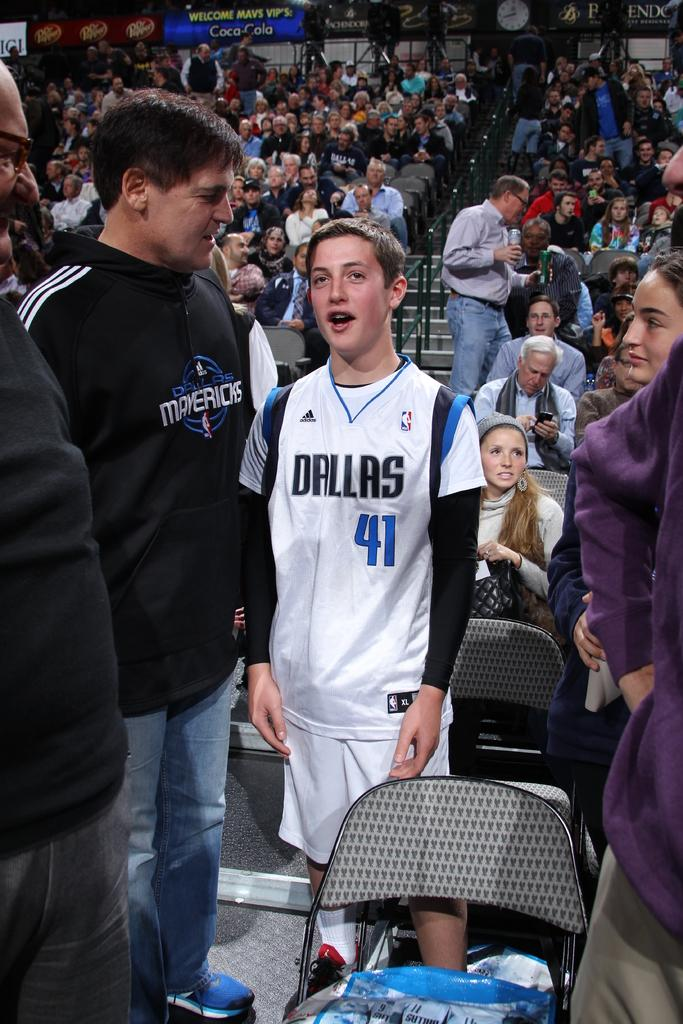<image>
Render a clear and concise summary of the photo. Boy wearing a basketball jersey which says Dallas number 41. 